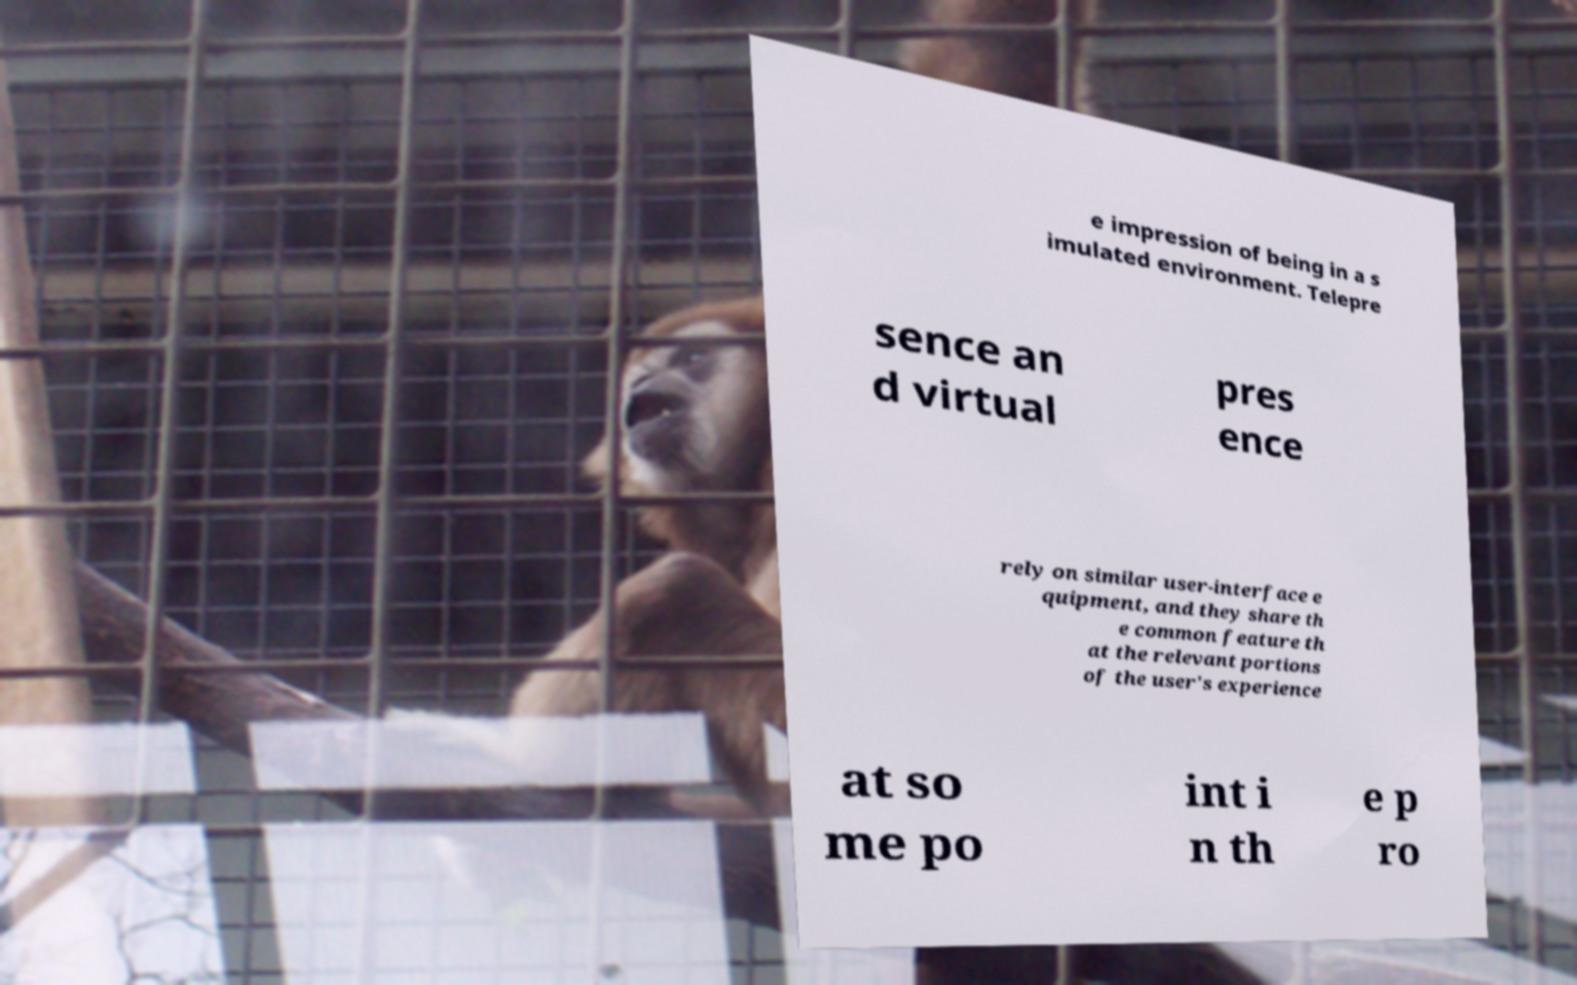Please identify and transcribe the text found in this image. e impression of being in a s imulated environment. Telepre sence an d virtual pres ence rely on similar user-interface e quipment, and they share th e common feature th at the relevant portions of the user's experience at so me po int i n th e p ro 